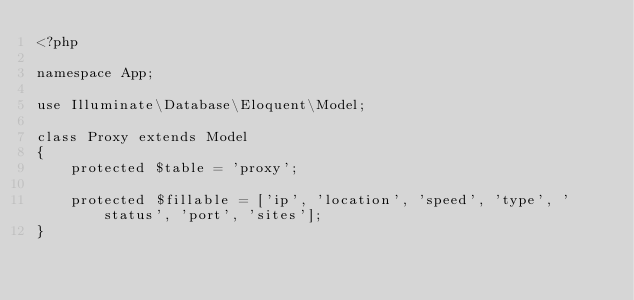Convert code to text. <code><loc_0><loc_0><loc_500><loc_500><_PHP_><?php

namespace App;

use Illuminate\Database\Eloquent\Model;

class Proxy extends Model
{
    protected $table = 'proxy';

    protected $fillable = ['ip', 'location', 'speed', 'type', 'status', 'port', 'sites'];
}
</code> 